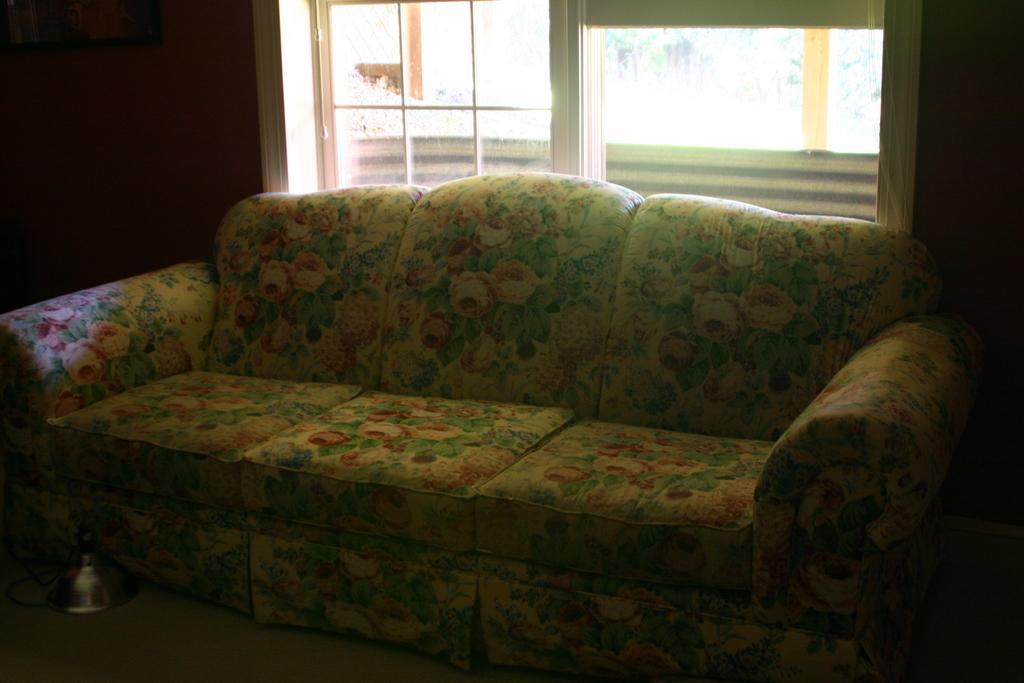Describe this image in one or two sentences. In this picture there is a sofa in the room with flower design hand back side of it there is a window. 